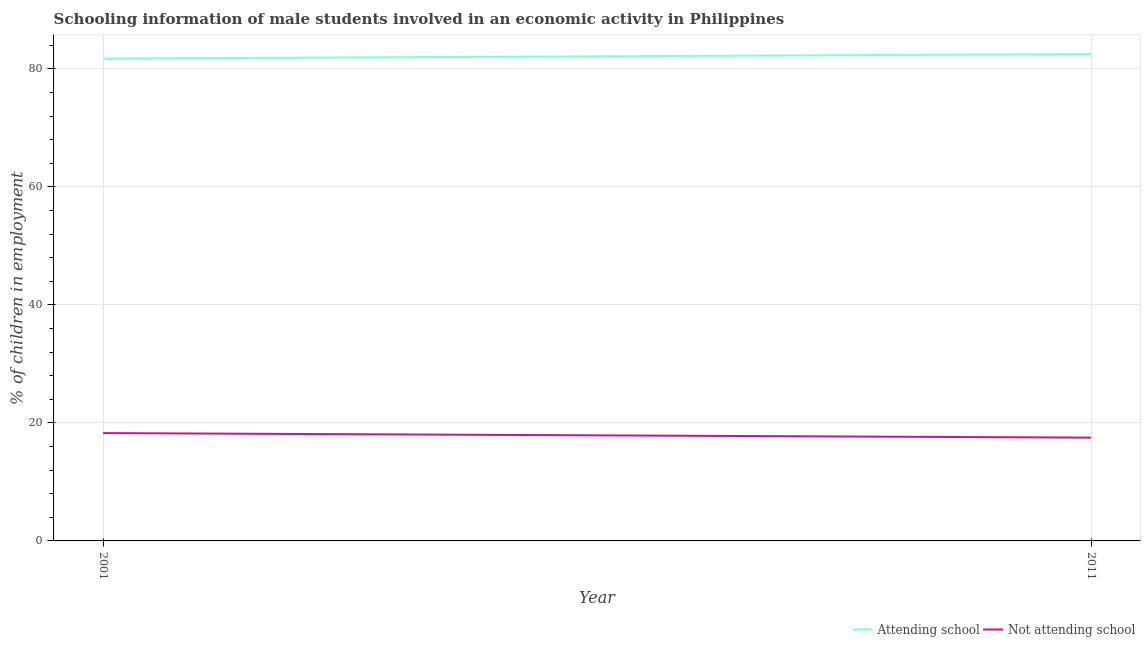Is the number of lines equal to the number of legend labels?
Ensure brevity in your answer.  Yes. What is the percentage of employed males who are attending school in 2001?
Give a very brief answer. 81.73. Across all years, what is the maximum percentage of employed males who are not attending school?
Ensure brevity in your answer.  18.27. Across all years, what is the minimum percentage of employed males who are attending school?
Provide a short and direct response. 81.73. What is the total percentage of employed males who are attending school in the graph?
Keep it short and to the point. 164.23. What is the difference between the percentage of employed males who are attending school in 2001 and that in 2011?
Offer a very short reply. -0.77. What is the difference between the percentage of employed males who are attending school in 2011 and the percentage of employed males who are not attending school in 2001?
Your answer should be compact. 64.23. What is the average percentage of employed males who are attending school per year?
Your answer should be compact. 82.11. In the year 2001, what is the difference between the percentage of employed males who are not attending school and percentage of employed males who are attending school?
Provide a short and direct response. -63.45. What is the ratio of the percentage of employed males who are attending school in 2001 to that in 2011?
Your answer should be very brief. 0.99. Does the percentage of employed males who are attending school monotonically increase over the years?
Offer a terse response. Yes. Is the percentage of employed males who are attending school strictly less than the percentage of employed males who are not attending school over the years?
Your response must be concise. No. How many lines are there?
Your response must be concise. 2. Are the values on the major ticks of Y-axis written in scientific E-notation?
Offer a terse response. No. Does the graph contain grids?
Your response must be concise. Yes. How many legend labels are there?
Provide a succinct answer. 2. How are the legend labels stacked?
Offer a terse response. Horizontal. What is the title of the graph?
Your response must be concise. Schooling information of male students involved in an economic activity in Philippines. What is the label or title of the X-axis?
Offer a very short reply. Year. What is the label or title of the Y-axis?
Your answer should be very brief. % of children in employment. What is the % of children in employment in Attending school in 2001?
Your response must be concise. 81.73. What is the % of children in employment of Not attending school in 2001?
Ensure brevity in your answer.  18.27. What is the % of children in employment in Attending school in 2011?
Provide a short and direct response. 82.5. Across all years, what is the maximum % of children in employment in Attending school?
Ensure brevity in your answer.  82.5. Across all years, what is the maximum % of children in employment of Not attending school?
Your answer should be compact. 18.27. Across all years, what is the minimum % of children in employment of Attending school?
Your answer should be compact. 81.73. What is the total % of children in employment in Attending school in the graph?
Offer a terse response. 164.23. What is the total % of children in employment in Not attending school in the graph?
Offer a very short reply. 35.77. What is the difference between the % of children in employment in Attending school in 2001 and that in 2011?
Ensure brevity in your answer.  -0.77. What is the difference between the % of children in employment in Not attending school in 2001 and that in 2011?
Offer a very short reply. 0.77. What is the difference between the % of children in employment in Attending school in 2001 and the % of children in employment in Not attending school in 2011?
Provide a succinct answer. 64.23. What is the average % of children in employment of Attending school per year?
Your answer should be very brief. 82.11. What is the average % of children in employment in Not attending school per year?
Keep it short and to the point. 17.89. In the year 2001, what is the difference between the % of children in employment of Attending school and % of children in employment of Not attending school?
Keep it short and to the point. 63.45. What is the ratio of the % of children in employment in Attending school in 2001 to that in 2011?
Keep it short and to the point. 0.99. What is the ratio of the % of children in employment of Not attending school in 2001 to that in 2011?
Your answer should be very brief. 1.04. What is the difference between the highest and the second highest % of children in employment in Attending school?
Offer a terse response. 0.77. What is the difference between the highest and the second highest % of children in employment in Not attending school?
Make the answer very short. 0.77. What is the difference between the highest and the lowest % of children in employment in Attending school?
Keep it short and to the point. 0.77. What is the difference between the highest and the lowest % of children in employment of Not attending school?
Your answer should be compact. 0.77. 